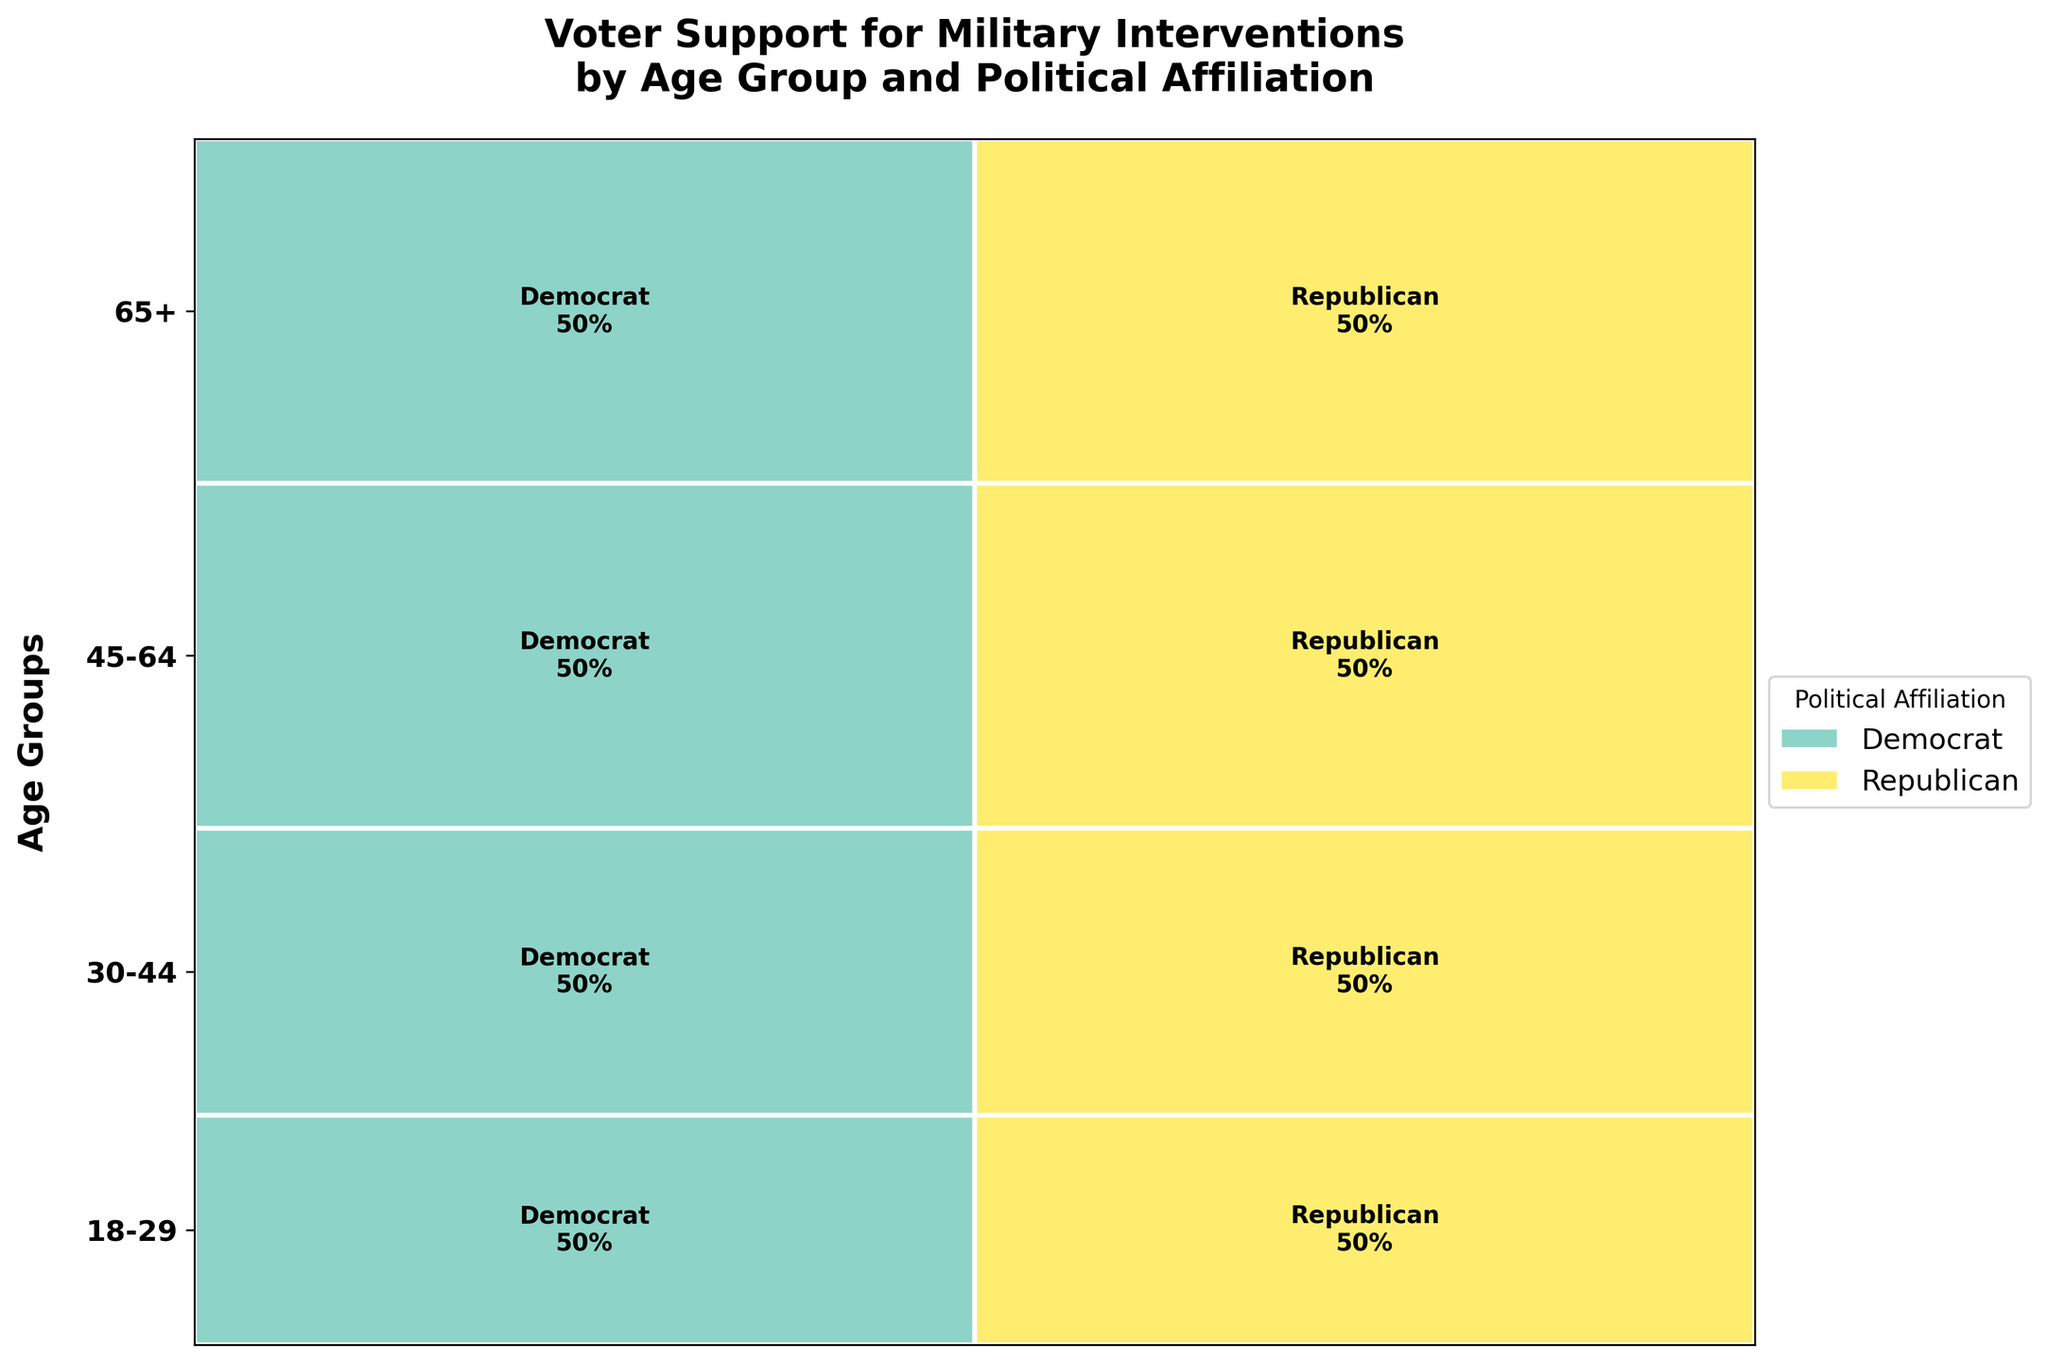Which age group has the highest proportion of high support from Republicans? To answer this, examine the rectangles representing Republicans in each age group. The proportion is indicated by the height of the rectangles. The tallest rectangle representing the "high" support of Republicans is found in the 65+ age group.
Answer: 65+ What proportion of Democrats aged 18-29 have low support for military interventions? Look at the section for the 18-29 age group and identify the rectangle for Democrats with low support. The label should indicate the respective proportion. In this case, it is 60%.
Answer: 60% Which age group has the most balanced support levels between high and low support for military interventions among Democrats? Calculate the difference between high and low support proportions for Democrats within each age group. The age group where this difference is smallest will be the most balanced. For the 30-44 age group, the differences are smaller compared to other groups.
Answer: 30-44 Is there any age group where Republicans have a larger proportion of low support than high support? Compare the heights of rectangles representing low and high supports within Republican columns across age groups. There is no such age group; in each case, high support exceeds low support.
Answer: No For voters aged 45-64, which political affiliation shows higher support levels for military interventions? Within the 45-64 age group, compare the height of the rectangles for high support levels across political affiliations. Republicans show a higher support level than Democrats.
Answer: Republican What is the total proportion of Republicans across all age groups supporting high military interventions? Individually check the height proportions of high support Republicans in each age group and sum them up. 18-29: 65%, 30-44: 64%, 45-64: 63%, 65+: 73%. Summing these up gives 265%. Divide by the number of age groups (4), yielding roughly 66.25%.
Answer: 66.25% Which age group shows the highest discrepancy between Democratic and Republican support for military interventions? Look for the age group where the difference between heights of Democratic and Republican rectangles (high or low) is maximum. The largest difference is observed in 65+, where Republicans have a much higher proportion of high support compared to Democrats.
Answer: 65+ Which political affiliation shows more variance in support levels across different age groups? Assess the differences between high and low proportions of support across age groups for both Democrats and Republicans. Democrats show less variance compared to Republicans, as Republican support varies more sharply between high and low across age groups.
Answer: Republican In which age group do Democrats have a higher proportion of high support than low support? Look for age groups where the rectangle for Democrats' high support is taller than that for low support. There is no such age group; in all age groups, low support among Democrats is higher.
Answer: None What is the percentage of Republican high support for military interventions in the 30-44 age group? Identify the 30-44 age group, look at the proportion label for high support among Republicans. The label reads 64%.
Answer: 64% 